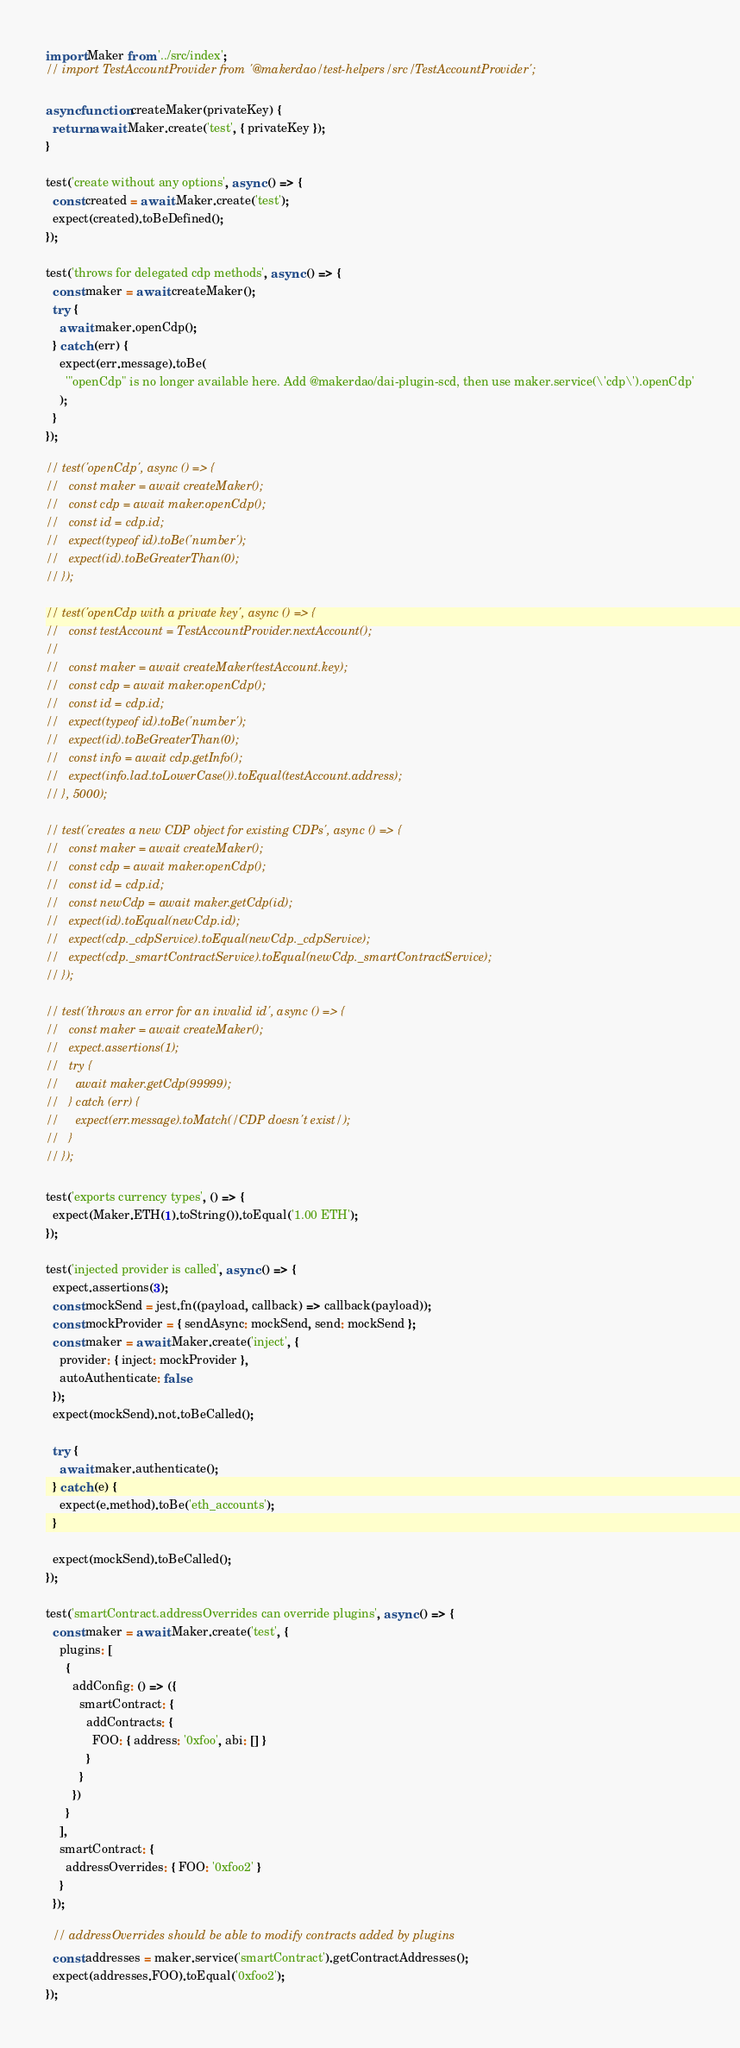<code> <loc_0><loc_0><loc_500><loc_500><_JavaScript_>import Maker from '../src/index';
// import TestAccountProvider from '@makerdao/test-helpers/src/TestAccountProvider';

async function createMaker(privateKey) {
  return await Maker.create('test', { privateKey });
}

test('create without any options', async () => {
  const created = await Maker.create('test');
  expect(created).toBeDefined();
});

test('throws for delegated cdp methods', async () => {
  const maker = await createMaker();
  try {
    await maker.openCdp();
  } catch (err) {
    expect(err.message).toBe(
      '"openCdp" is no longer available here. Add @makerdao/dai-plugin-scd, then use maker.service(\'cdp\').openCdp'
    );
  }
});

// test('openCdp', async () => {
//   const maker = await createMaker();
//   const cdp = await maker.openCdp();
//   const id = cdp.id;
//   expect(typeof id).toBe('number');
//   expect(id).toBeGreaterThan(0);
// });

// test('openCdp with a private key', async () => {
//   const testAccount = TestAccountProvider.nextAccount();
//
//   const maker = await createMaker(testAccount.key);
//   const cdp = await maker.openCdp();
//   const id = cdp.id;
//   expect(typeof id).toBe('number');
//   expect(id).toBeGreaterThan(0);
//   const info = await cdp.getInfo();
//   expect(info.lad.toLowerCase()).toEqual(testAccount.address);
// }, 5000);

// test('creates a new CDP object for existing CDPs', async () => {
//   const maker = await createMaker();
//   const cdp = await maker.openCdp();
//   const id = cdp.id;
//   const newCdp = await maker.getCdp(id);
//   expect(id).toEqual(newCdp.id);
//   expect(cdp._cdpService).toEqual(newCdp._cdpService);
//   expect(cdp._smartContractService).toEqual(newCdp._smartContractService);
// });

// test('throws an error for an invalid id', async () => {
//   const maker = await createMaker();
//   expect.assertions(1);
//   try {
//     await maker.getCdp(99999);
//   } catch (err) {
//     expect(err.message).toMatch(/CDP doesn't exist/);
//   }
// });

test('exports currency types', () => {
  expect(Maker.ETH(1).toString()).toEqual('1.00 ETH');
});

test('injected provider is called', async () => {
  expect.assertions(3);
  const mockSend = jest.fn((payload, callback) => callback(payload));
  const mockProvider = { sendAsync: mockSend, send: mockSend };
  const maker = await Maker.create('inject', {
    provider: { inject: mockProvider },
    autoAuthenticate: false
  });
  expect(mockSend).not.toBeCalled();

  try {
    await maker.authenticate();
  } catch (e) {
    expect(e.method).toBe('eth_accounts');
  }

  expect(mockSend).toBeCalled();
});

test('smartContract.addressOverrides can override plugins', async () => {
  const maker = await Maker.create('test', {
    plugins: [
      {
        addConfig: () => ({
          smartContract: {
            addContracts: {
              FOO: { address: '0xfoo', abi: [] }
            }
          }
        })
      }
    ],
    smartContract: {
      addressOverrides: { FOO: '0xfoo2' }
    }
  });

  // addressOverrides should be able to modify contracts added by plugins
  const addresses = maker.service('smartContract').getContractAddresses();
  expect(addresses.FOO).toEqual('0xfoo2');
});
</code> 